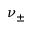Convert formula to latex. <formula><loc_0><loc_0><loc_500><loc_500>\nu _ { \pm }</formula> 